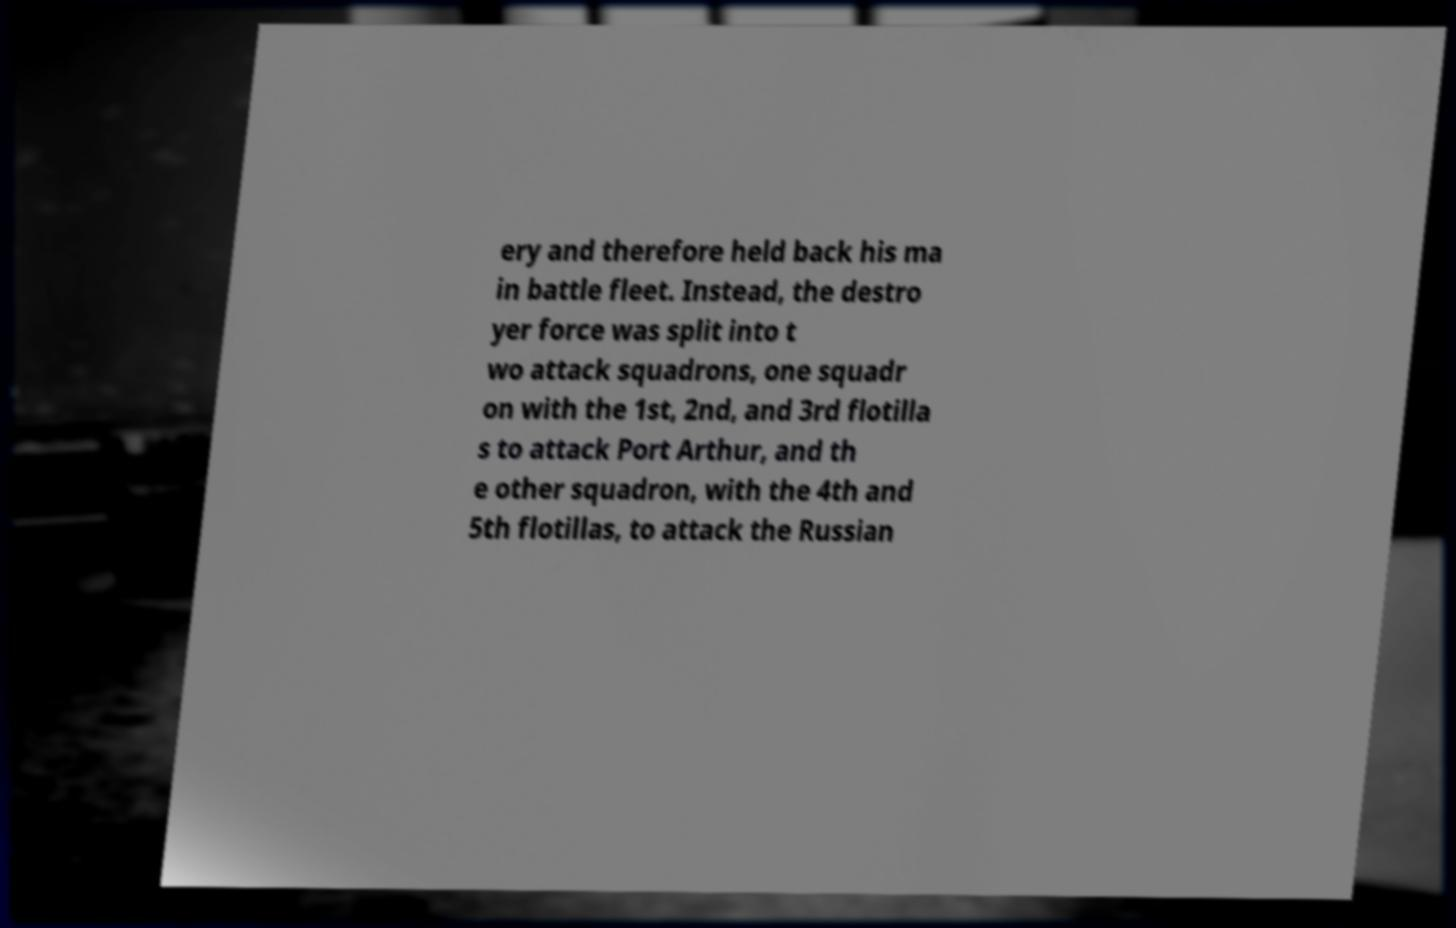I need the written content from this picture converted into text. Can you do that? ery and therefore held back his ma in battle fleet. Instead, the destro yer force was split into t wo attack squadrons, one squadr on with the 1st, 2nd, and 3rd flotilla s to attack Port Arthur, and th e other squadron, with the 4th and 5th flotillas, to attack the Russian 